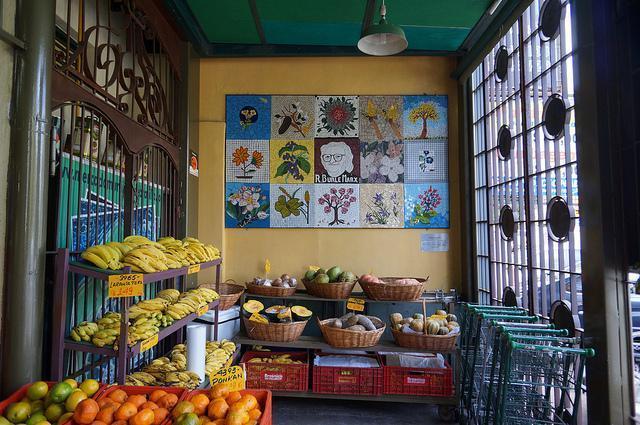How many oranges can be seen?
Give a very brief answer. 2. How many of the men are wearing a black shirt?
Give a very brief answer. 0. 